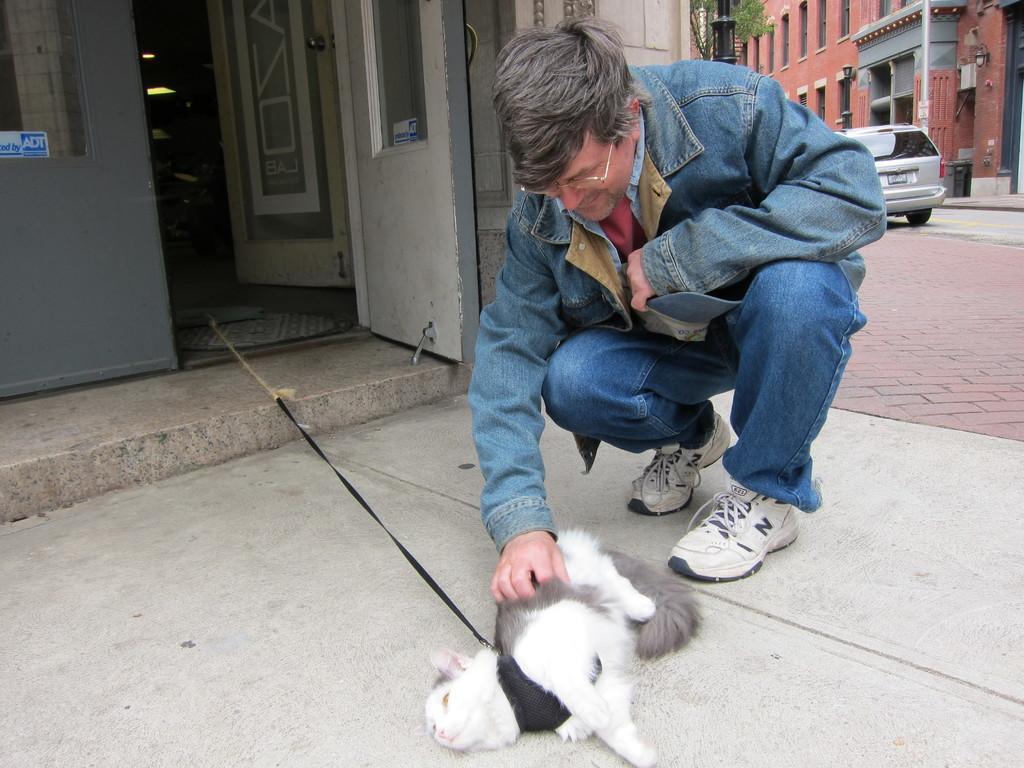Can you describe this image briefly? A man with blue jacket and blue jeans is sitting on the floor and kept his hand on the cat. To the left top corner there is a door. And beside that man there is a car on the road. And there is a building. 